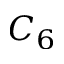Convert formula to latex. <formula><loc_0><loc_0><loc_500><loc_500>C _ { 6 }</formula> 